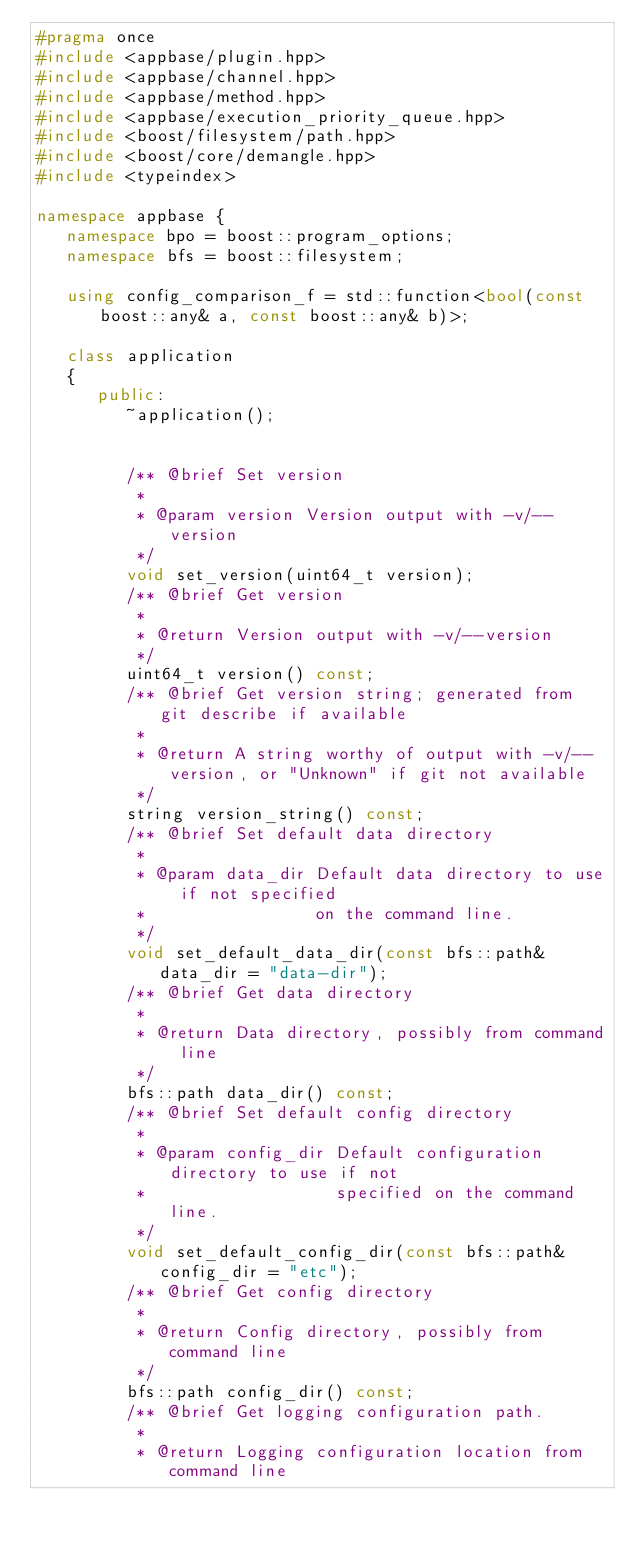Convert code to text. <code><loc_0><loc_0><loc_500><loc_500><_C++_>#pragma once
#include <appbase/plugin.hpp>
#include <appbase/channel.hpp>
#include <appbase/method.hpp>
#include <appbase/execution_priority_queue.hpp>
#include <boost/filesystem/path.hpp>
#include <boost/core/demangle.hpp>
#include <typeindex>

namespace appbase {
   namespace bpo = boost::program_options;
   namespace bfs = boost::filesystem;

   using config_comparison_f = std::function<bool(const boost::any& a, const boost::any& b)>;

   class application
   {
      public:
         ~application();


         /** @brief Set version
          *
          * @param version Version output with -v/--version
          */
         void set_version(uint64_t version);
         /** @brief Get version
          *
          * @return Version output with -v/--version
          */
         uint64_t version() const;
         /** @brief Get version string; generated from git describe if available
          *
          * @return A string worthy of output with -v/--version, or "Unknown" if git not available
          */
         string version_string() const;
         /** @brief Set default data directory
          *
          * @param data_dir Default data directory to use if not specified
          *                 on the command line.
          */
         void set_default_data_dir(const bfs::path& data_dir = "data-dir");
         /** @brief Get data directory
          *
          * @return Data directory, possibly from command line
          */
         bfs::path data_dir() const;
         /** @brief Set default config directory
          *
          * @param config_dir Default configuration directory to use if not
          *                   specified on the command line.
          */
         void set_default_config_dir(const bfs::path& config_dir = "etc");
         /** @brief Get config directory
          *
          * @return Config directory, possibly from command line
          */
         bfs::path config_dir() const;
         /** @brief Get logging configuration path.
          *
          * @return Logging configuration location from command line</code> 